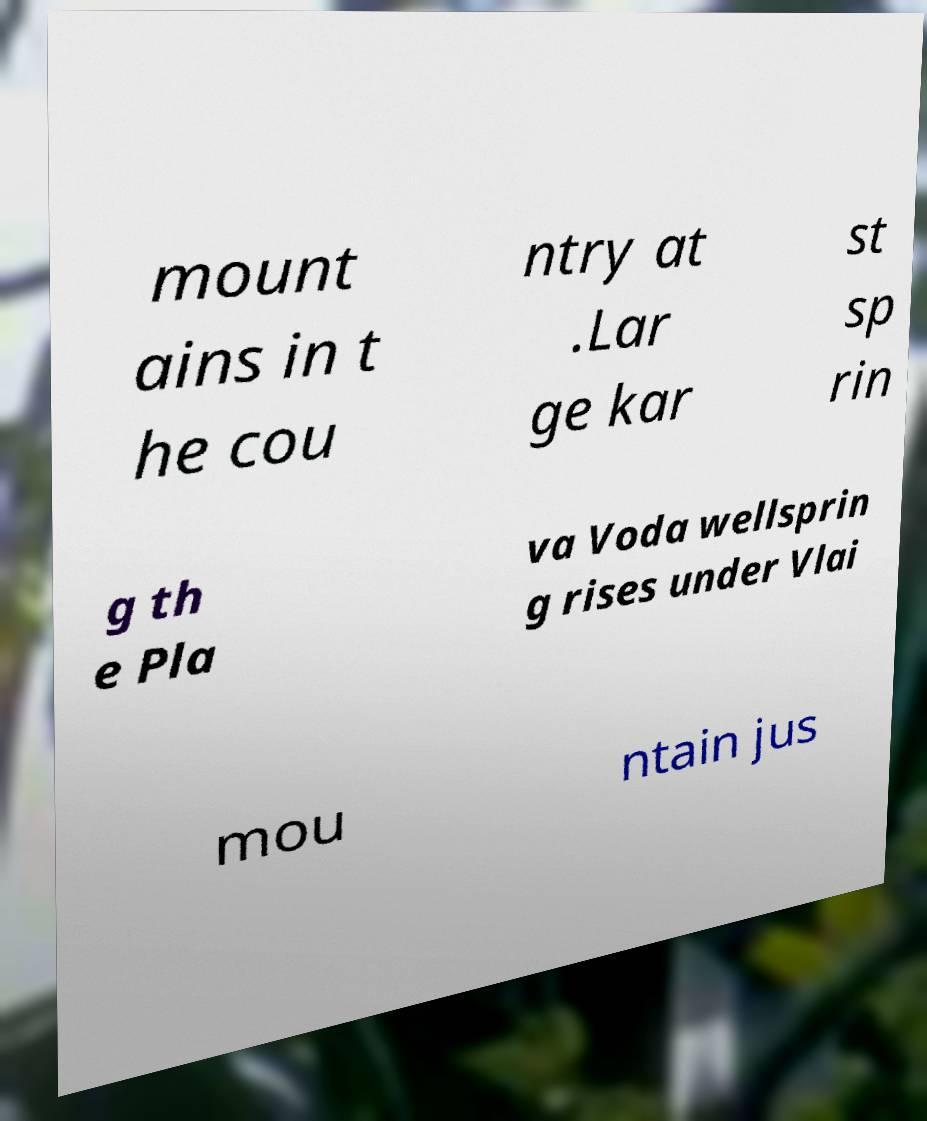Can you read and provide the text displayed in the image?This photo seems to have some interesting text. Can you extract and type it out for me? mount ains in t he cou ntry at .Lar ge kar st sp rin g th e Pla va Voda wellsprin g rises under Vlai mou ntain jus 